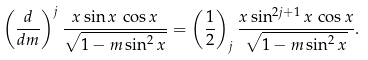Convert formula to latex. <formula><loc_0><loc_0><loc_500><loc_500>\left ( \frac { d } { d m } \right ) ^ { j } \frac { x \sin x \, \cos x } { \sqrt { 1 - m \sin ^ { 2 } x } } = \left ( \frac { 1 } { 2 } \right ) _ { j } \frac { x \sin ^ { 2 j + 1 } x \, \cos x } { \sqrt { 1 - m \sin ^ { 2 } x } } .</formula> 